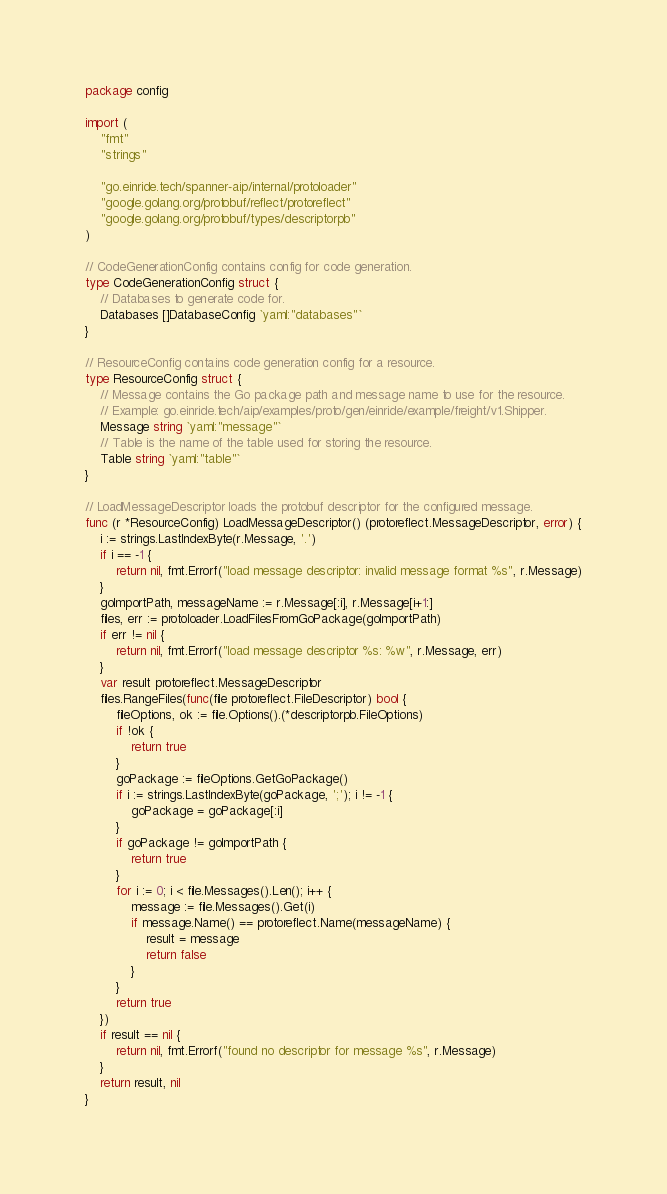<code> <loc_0><loc_0><loc_500><loc_500><_Go_>package config

import (
	"fmt"
	"strings"

	"go.einride.tech/spanner-aip/internal/protoloader"
	"google.golang.org/protobuf/reflect/protoreflect"
	"google.golang.org/protobuf/types/descriptorpb"
)

// CodeGenerationConfig contains config for code generation.
type CodeGenerationConfig struct {
	// Databases to generate code for.
	Databases []DatabaseConfig `yaml:"databases"`
}

// ResourceConfig contains code generation config for a resource.
type ResourceConfig struct {
	// Message contains the Go package path and message name to use for the resource.
	// Example: go.einride.tech/aip/examples/proto/gen/einride/example/freight/v1.Shipper.
	Message string `yaml:"message"`
	// Table is the name of the table used for storing the resource.
	Table string `yaml:"table"`
}

// LoadMessageDescriptor loads the protobuf descriptor for the configured message.
func (r *ResourceConfig) LoadMessageDescriptor() (protoreflect.MessageDescriptor, error) {
	i := strings.LastIndexByte(r.Message, '.')
	if i == -1 {
		return nil, fmt.Errorf("load message descriptor: invalid message format %s", r.Message)
	}
	goImportPath, messageName := r.Message[:i], r.Message[i+1:]
	files, err := protoloader.LoadFilesFromGoPackage(goImportPath)
	if err != nil {
		return nil, fmt.Errorf("load message descriptor %s: %w", r.Message, err)
	}
	var result protoreflect.MessageDescriptor
	files.RangeFiles(func(file protoreflect.FileDescriptor) bool {
		fileOptions, ok := file.Options().(*descriptorpb.FileOptions)
		if !ok {
			return true
		}
		goPackage := fileOptions.GetGoPackage()
		if i := strings.LastIndexByte(goPackage, ';'); i != -1 {
			goPackage = goPackage[:i]
		}
		if goPackage != goImportPath {
			return true
		}
		for i := 0; i < file.Messages().Len(); i++ {
			message := file.Messages().Get(i)
			if message.Name() == protoreflect.Name(messageName) {
				result = message
				return false
			}
		}
		return true
	})
	if result == nil {
		return nil, fmt.Errorf("found no descriptor for message %s", r.Message)
	}
	return result, nil
}
</code> 